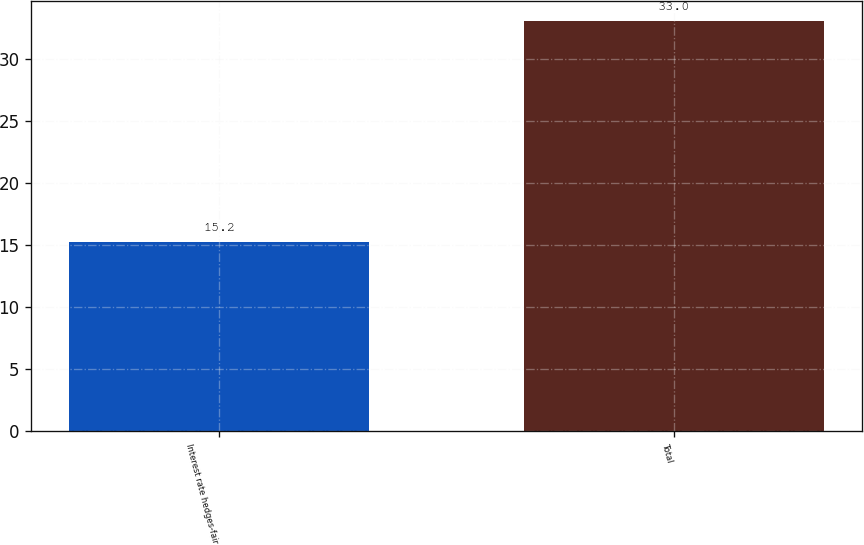Convert chart to OTSL. <chart><loc_0><loc_0><loc_500><loc_500><bar_chart><fcel>Interest rate hedges-fair<fcel>Total<nl><fcel>15.2<fcel>33<nl></chart> 